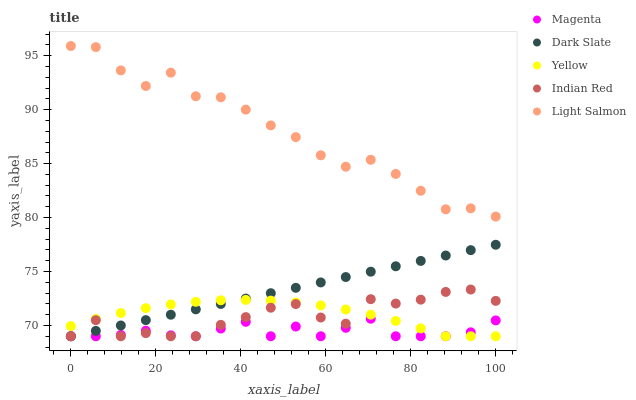Does Magenta have the minimum area under the curve?
Answer yes or no. Yes. Does Light Salmon have the maximum area under the curve?
Answer yes or no. Yes. Does Indian Red have the minimum area under the curve?
Answer yes or no. No. Does Indian Red have the maximum area under the curve?
Answer yes or no. No. Is Dark Slate the smoothest?
Answer yes or no. Yes. Is Light Salmon the roughest?
Answer yes or no. Yes. Is Magenta the smoothest?
Answer yes or no. No. Is Magenta the roughest?
Answer yes or no. No. Does Dark Slate have the lowest value?
Answer yes or no. Yes. Does Light Salmon have the lowest value?
Answer yes or no. No. Does Light Salmon have the highest value?
Answer yes or no. Yes. Does Indian Red have the highest value?
Answer yes or no. No. Is Dark Slate less than Light Salmon?
Answer yes or no. Yes. Is Light Salmon greater than Yellow?
Answer yes or no. Yes. Does Yellow intersect Magenta?
Answer yes or no. Yes. Is Yellow less than Magenta?
Answer yes or no. No. Is Yellow greater than Magenta?
Answer yes or no. No. Does Dark Slate intersect Light Salmon?
Answer yes or no. No. 